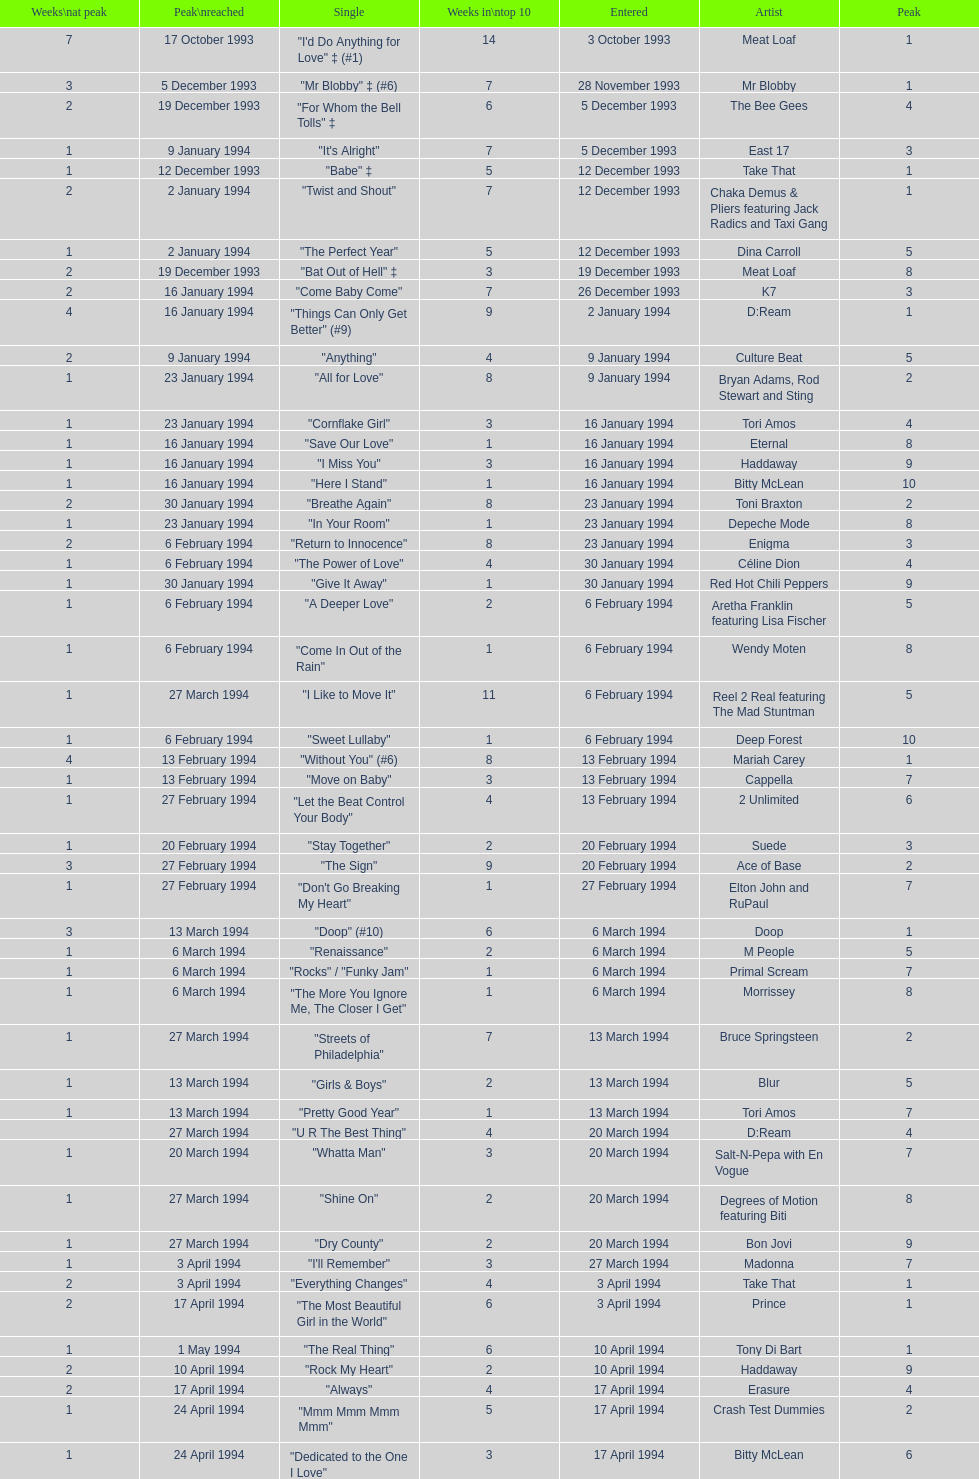Which single was the last one to be on the charts in 1993? "Come Baby Come". 